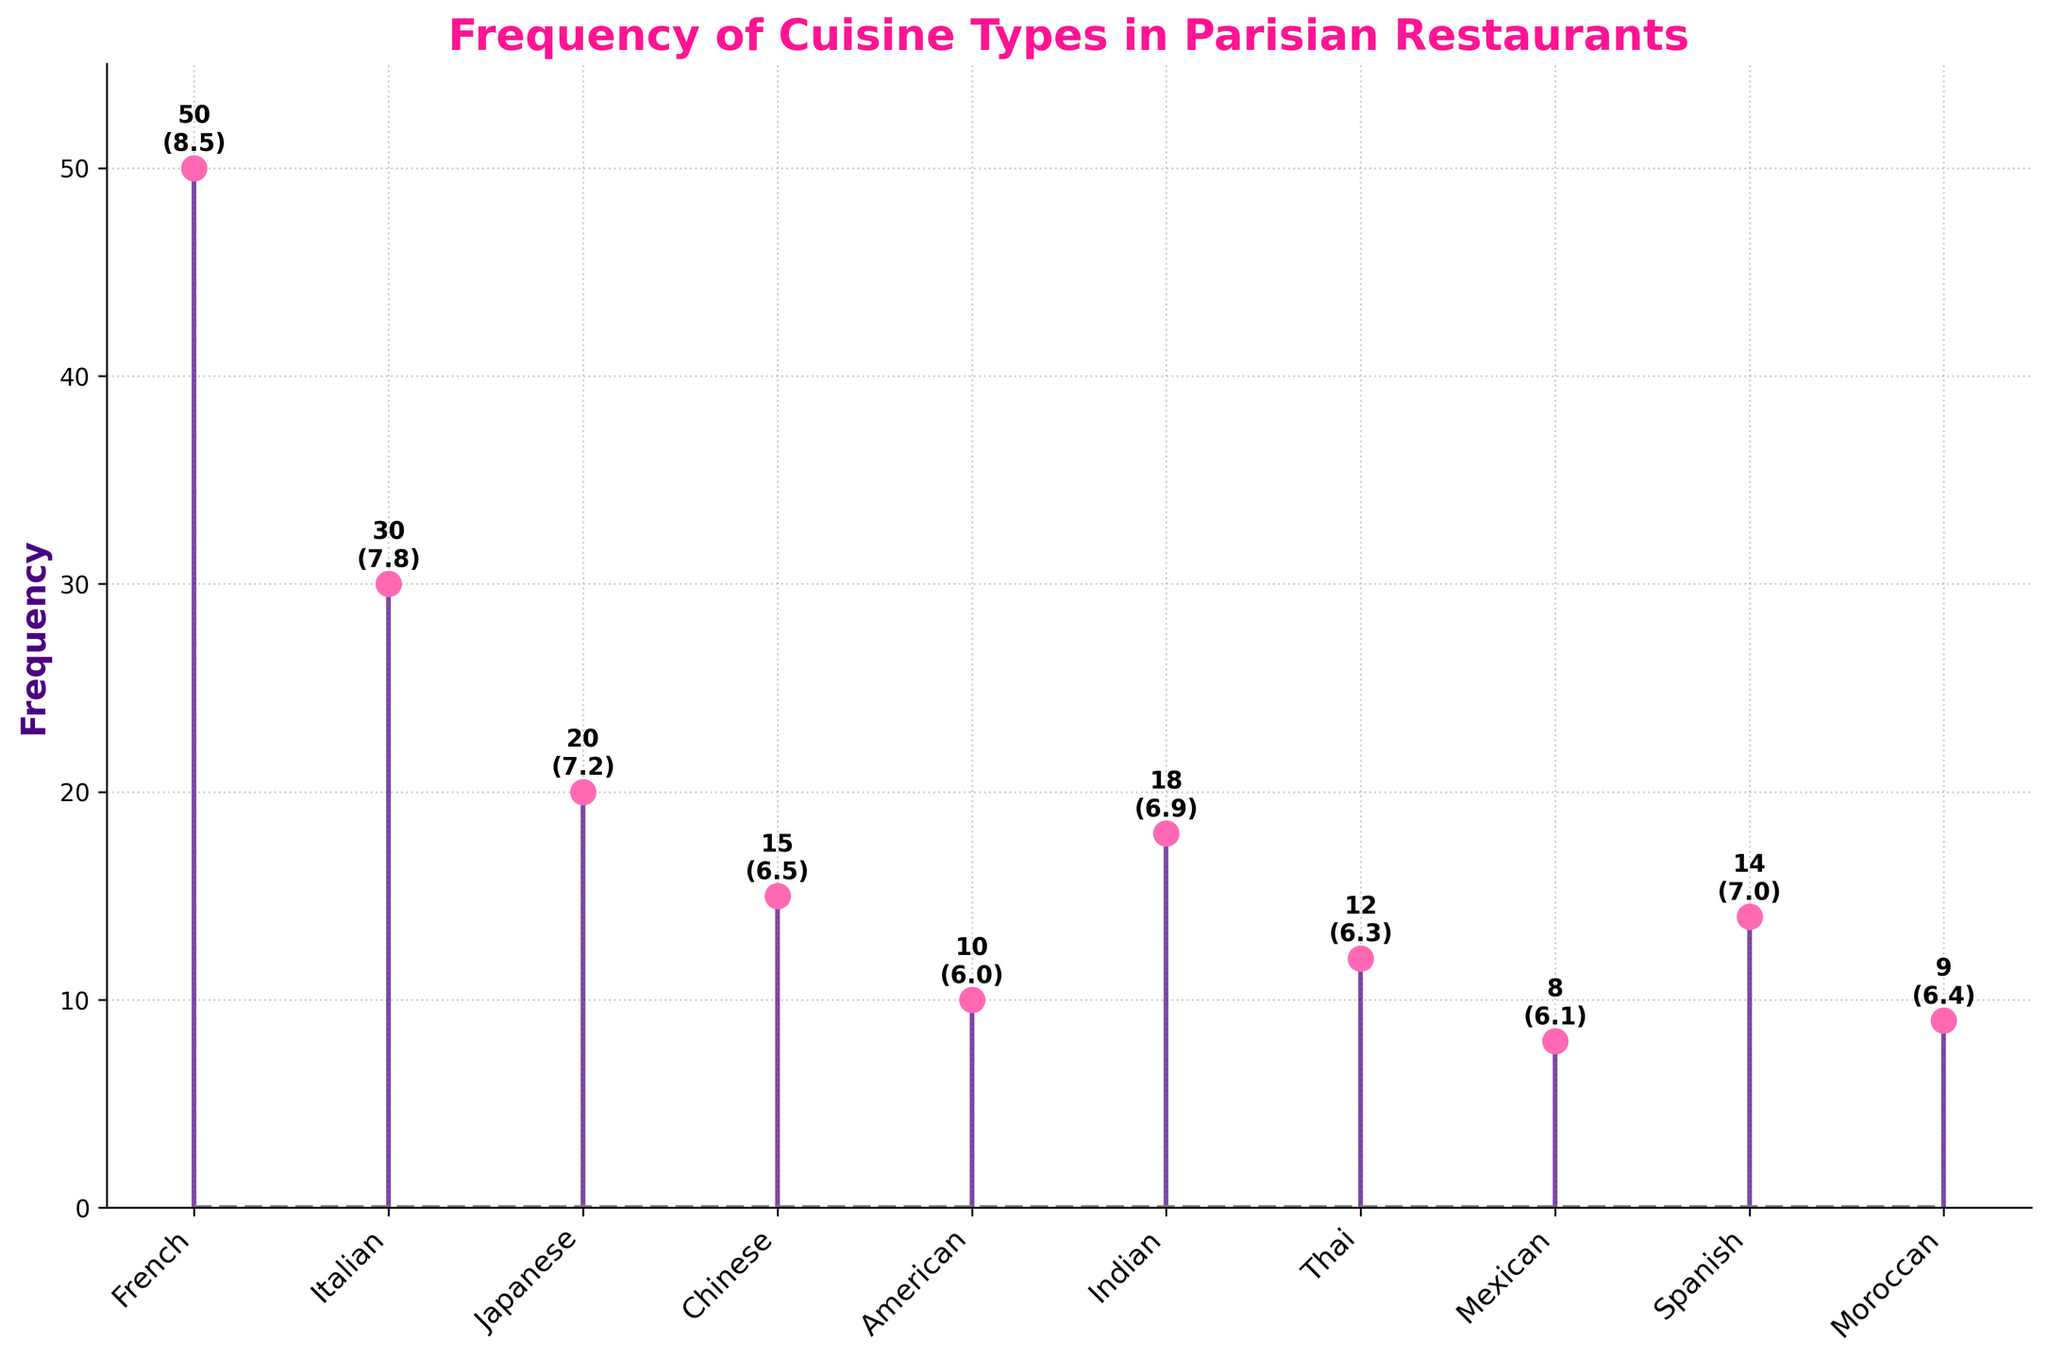What is the title of the plot? The title of the plot is usually displayed at the top of the plot. In this case, it reads "Frequency of Cuisine Types in Parisian Restaurants".
Answer: Frequency of Cuisine Types in Parisian Restaurants How is the frequency of each cuisine represented in the plot? The frequency of each cuisine type is represented by vertical lines (stems) extending from a baseline, with markers on top of each stem.
Answer: Vertical lines and markers Which cuisine has the highest frequency? By looking at the stems, the tallest one represents the cuisine with the highest frequency. The French cuisine has the tallest stem, indicating it has the highest frequency.
Answer: French How many cuisines have a frequency of 15 or above? By observing the heights of the stems, the French, Italian, Japanese, Chinese, Indian, and Spanish cuisines have frequencies of 15 or above. This totals to 6 cuisines.
Answer: 6 What is the frequency of Italian cuisine? The stem for Italian cuisine reaches up to a value of 30.
Answer: 30 Which cuisine is least popular based on the popularity rating? The annotations near the stem markers show the popularity ratings. The American cuisine has a popularity rating of 6.0, which is the lowest among all.
Answer: American What is the frequency difference between Japanese and Chinese cuisines? The frequency of Japanese cuisine is 20, and the frequency of Chinese cuisine is 15. The difference is 20 - 15 = 5.
Answer: 5 On average, how popular are Thai and Mexican cuisines? The popularity of Thai cuisine is 6.3 and Mexican cuisine is 6.1. The average popularity is (6.3 + 6.1) / 2 = 6.2.
Answer: 6.2 Which cuisines have a popularity rating higher than 7.0? Cuisines with popularity ratings higher than 7.0 are French (8.5), Italian (7.8), and Spanish (7.0).
Answer: French, Italian, Spanish Are there more Asian cuisines or European cuisines represented in the plot? Asian cuisines include Japanese, Chinese, Thai, Indian, and Moroccan (5). European cuisines include French, Italian, Spanish (3). There are more Asian cuisines (5 > 3).
Answer: Asian cuisines What colors are used for the stemlines and markers? The stemlines are colored in a shade of indigo, and the markers are colored in pink.
Answer: Indigo and pink 